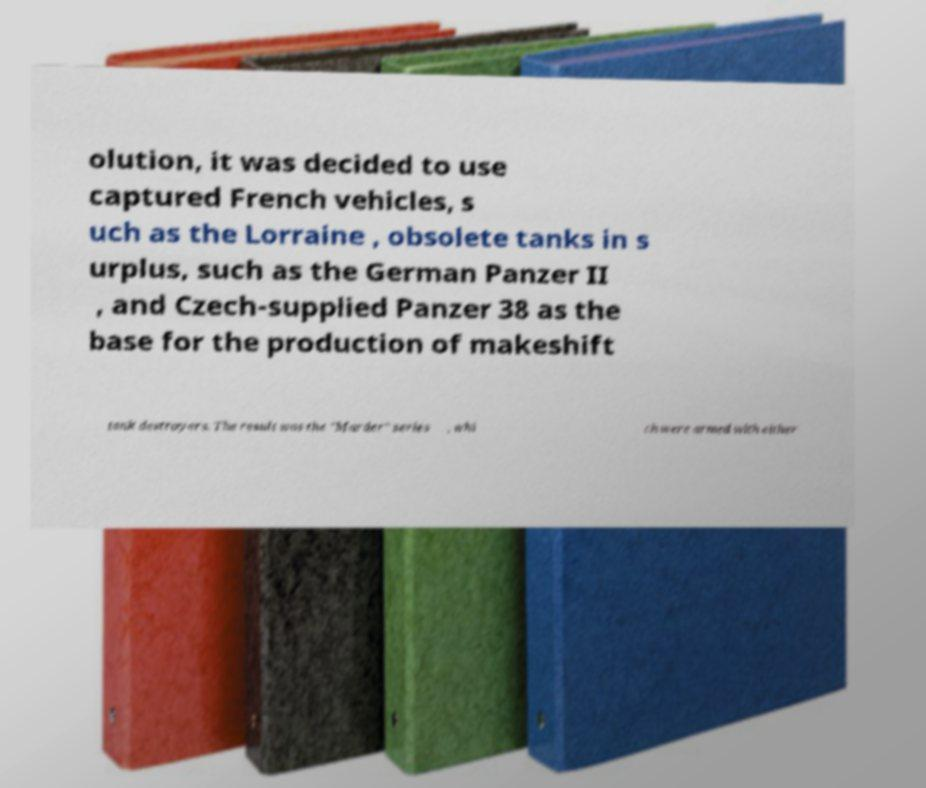Can you read and provide the text displayed in the image?This photo seems to have some interesting text. Can you extract and type it out for me? olution, it was decided to use captured French vehicles, s uch as the Lorraine , obsolete tanks in s urplus, such as the German Panzer II , and Czech-supplied Panzer 38 as the base for the production of makeshift tank destroyers. The result was the "Marder" series , whi ch were armed with either 